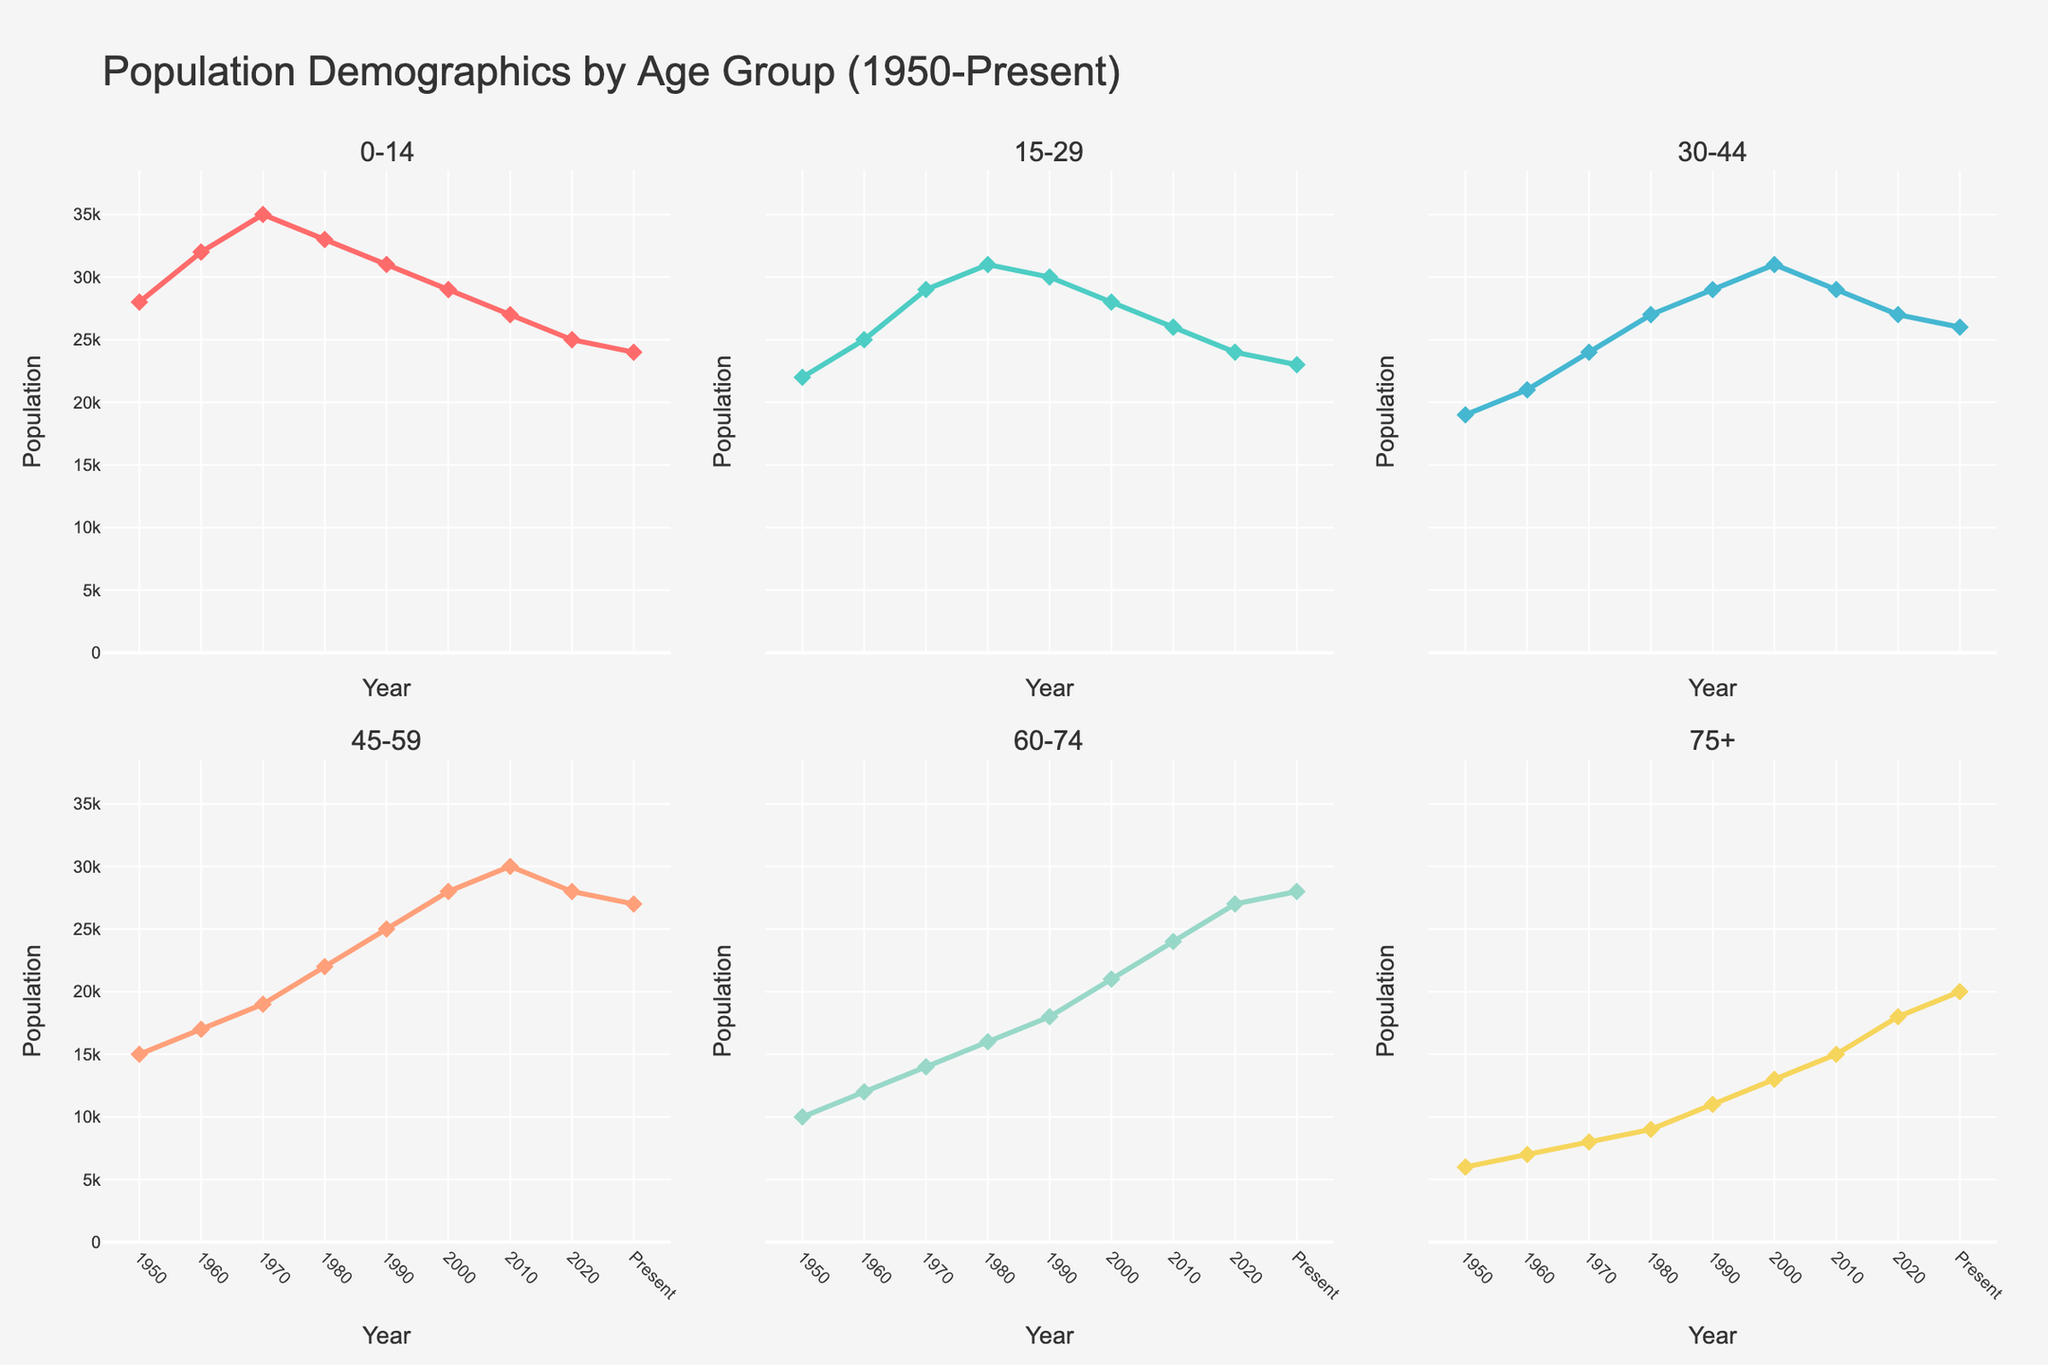How many age groups are displayed in the plots? The figure is divided into subplots, each representing a different age group. By counting the subplot titles, we find there are 6 age groups displayed.
Answer: 6 Which age group shows the highest population in the year 1950? By observing the population values for each age group in 1950, the age group 0-14 has the highest population of 28,000.
Answer: 0-14 What is the trend of the population for the age group 30-44 from 1950 to the present? The population for the age group 30-44 shows a general trend where it initially increases, peaks around the year 2000, and then slightly decreases towards the present.
Answer: Initially increasing, peaks around 2000, then decreases Which age group has shown the most consistent population growth from 1950 to the present? By looking at the subplots, the age group 60-74 demonstrates a consistent upward trend in population from 1950 to the present.
Answer: 60-74 What was the population of the 75+ age group in the year 2020? By locating the year 2020 on the x-axis and reading the corresponding value on the y-axis in the subplot for the 75+ age group, we find the population was 18,000.
Answer: 18,000 Compare the population of the age group 15-29 in 1980 and 2000. Which year had a higher population, and by how much? In 1980, the population for the age group 15-29 was 31,000, whereas in 2000 it was 28,000. Therefore, in 1980 it was higher by 3,000.
Answer: 1980, by 3,000 Which age group experienced a population decline from 2010 to 2020? By comparing the data points for 2010 and 2020 across all age groups, we see that the age groups 0-14, 15-29, and 30-44 experienced a decline.
Answer: 0-14, 15-29, 30-44 Calculate the average population for the age group 45-59 between 1950 and the present. The population values for the age group 45-59 are: 15,000, 17,000, 19,000, 22,000, 25,000, 28,000, 30,000, 28,000, 27,000. Summing these values gives 211,000, and there are 9 data points, so the average is approximately 23,444.
Answer: 23,444 Identify the age group that had the lowest population in the year 2000. By examining the population values for each age group in the year 2000, the age group 75+ had the lowest population of 13,000.
Answer: 75+ Which age groups showed an increase in population from 1980 to 1990? By comparing the data points for 1980 and 1990 across all age groups, the groups 45-59, 60-74, and 75+ showed an increase in population.
Answer: 45-59, 60-74, 75+ 